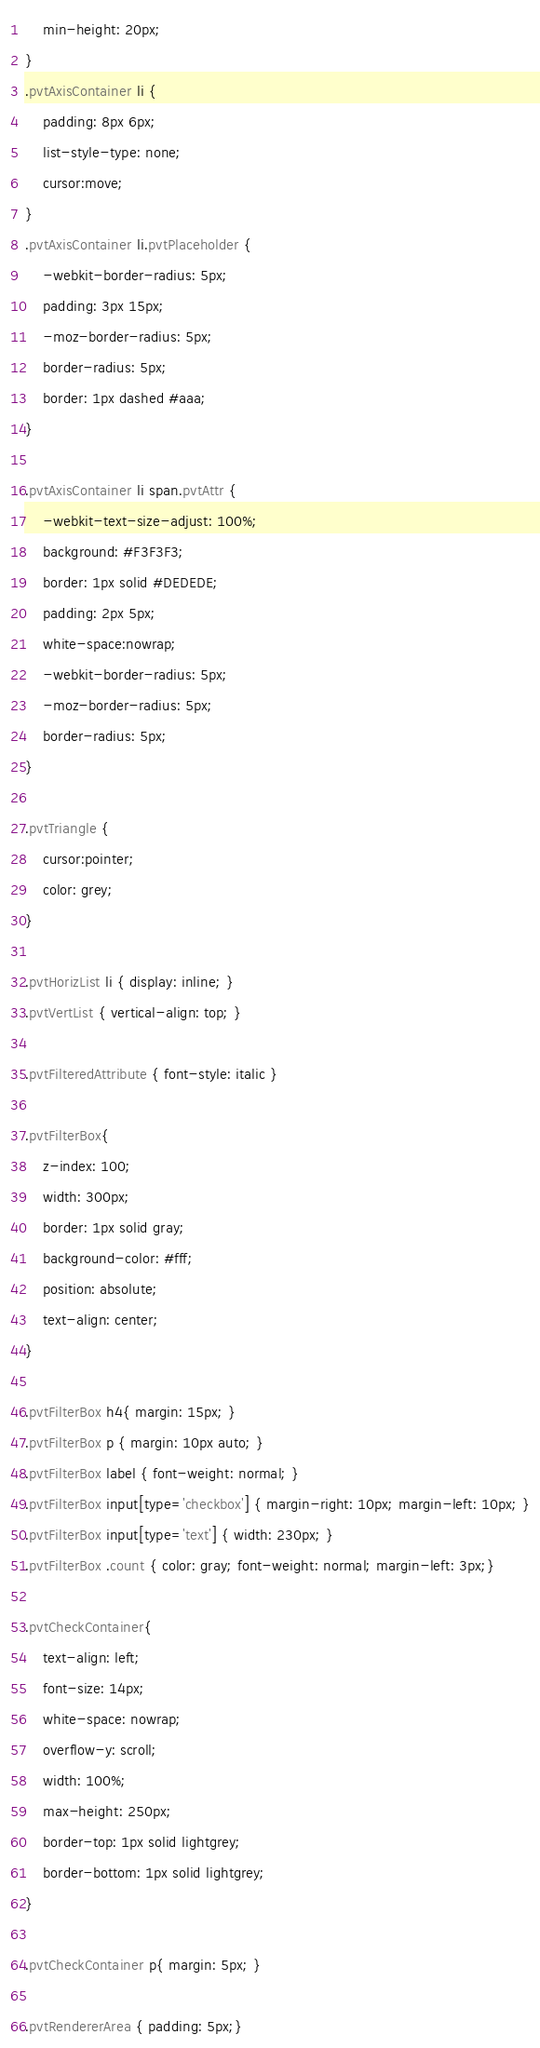<code> <loc_0><loc_0><loc_500><loc_500><_CSS_>    min-height: 20px;
}
.pvtAxisContainer li {
    padding: 8px 6px;
    list-style-type: none;
    cursor:move;
}
.pvtAxisContainer li.pvtPlaceholder {
    -webkit-border-radius: 5px;
    padding: 3px 15px;
    -moz-border-radius: 5px;
    border-radius: 5px;
    border: 1px dashed #aaa;
}

.pvtAxisContainer li span.pvtAttr {
    -webkit-text-size-adjust: 100%;
    background: #F3F3F3;
    border: 1px solid #DEDEDE;
    padding: 2px 5px;
    white-space:nowrap;
    -webkit-border-radius: 5px;
    -moz-border-radius: 5px;
    border-radius: 5px;
}

.pvtTriangle {
    cursor:pointer;
    color: grey;
}

.pvtHorizList li { display: inline; }
.pvtVertList { vertical-align: top; }

.pvtFilteredAttribute { font-style: italic }

.pvtFilterBox{
    z-index: 100;
    width: 300px;
    border: 1px solid gray;
    background-color: #fff;
    position: absolute;
    text-align: center;
}

.pvtFilterBox h4{ margin: 15px; }
.pvtFilterBox p { margin: 10px auto; }
.pvtFilterBox label { font-weight: normal; }
.pvtFilterBox input[type='checkbox'] { margin-right: 10px; margin-left: 10px; }
.pvtFilterBox input[type='text'] { width: 230px; }
.pvtFilterBox .count { color: gray; font-weight: normal; margin-left: 3px;}

.pvtCheckContainer{
    text-align: left;
    font-size: 14px;
    white-space: nowrap;
    overflow-y: scroll;
    width: 100%;
    max-height: 250px;
    border-top: 1px solid lightgrey;
    border-bottom: 1px solid lightgrey;
}

.pvtCheckContainer p{ margin: 5px; }

.pvtRendererArea { padding: 5px;}
</code> 